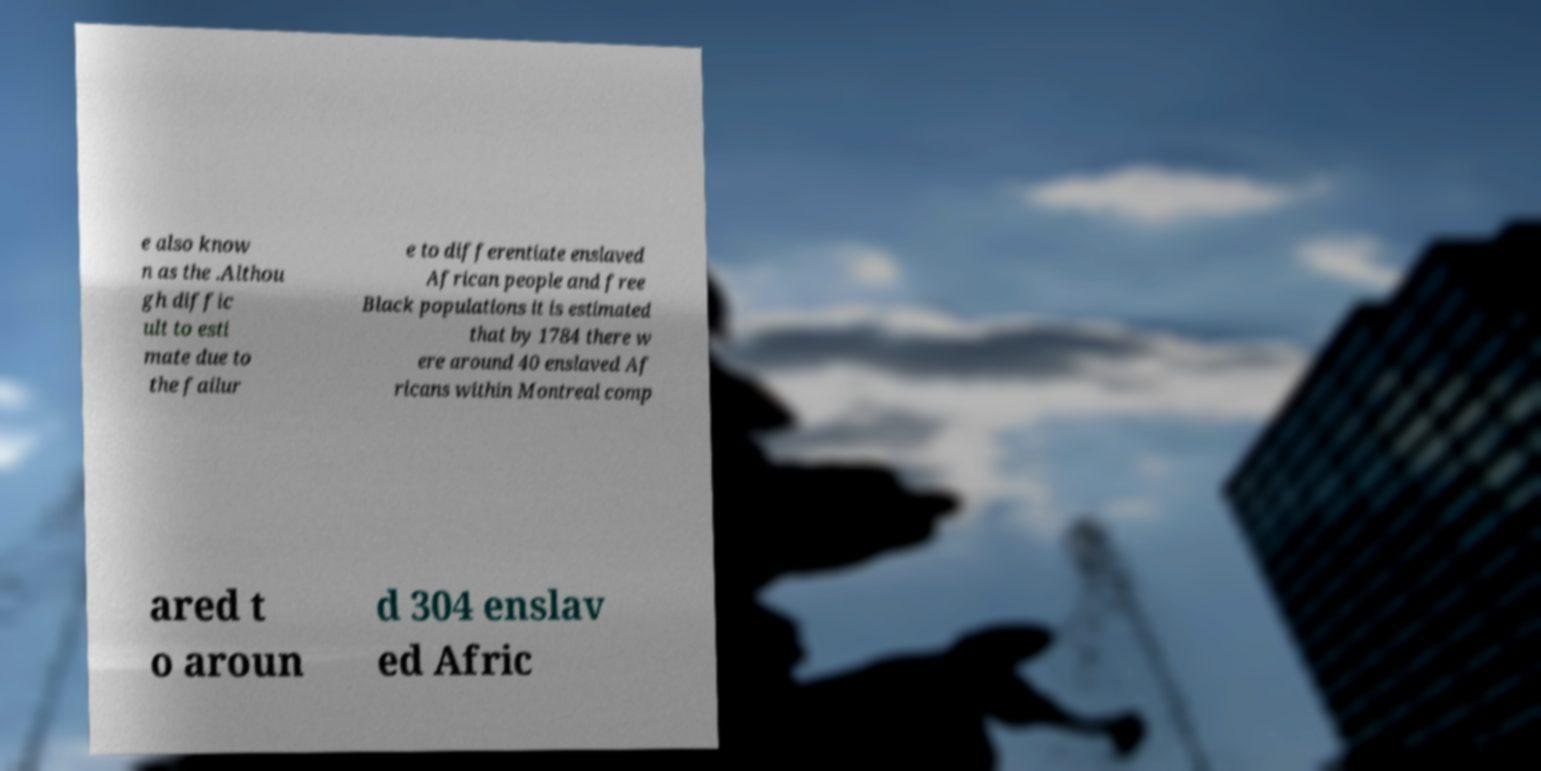What messages or text are displayed in this image? I need them in a readable, typed format. e also know n as the .Althou gh diffic ult to esti mate due to the failur e to differentiate enslaved African people and free Black populations it is estimated that by 1784 there w ere around 40 enslaved Af ricans within Montreal comp ared t o aroun d 304 enslav ed Afric 